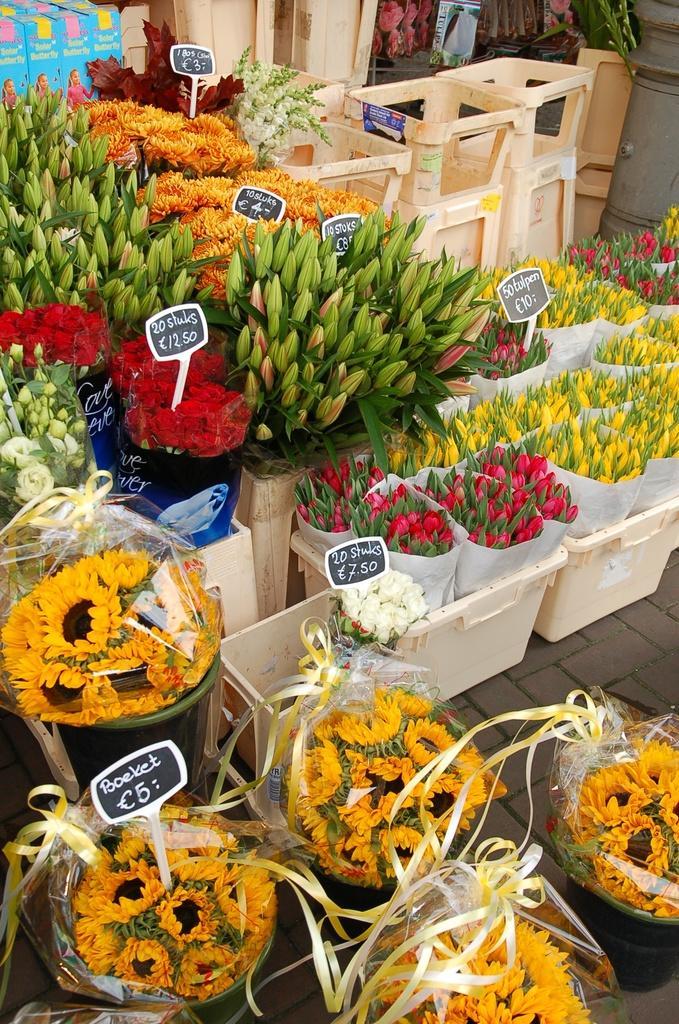Can you describe this image briefly? In this image we can see group of flowers placed in several containers on the ground. Some ribbons are tied to the flowers. In the background we can see group of stools ,a pole and some sign boards. 